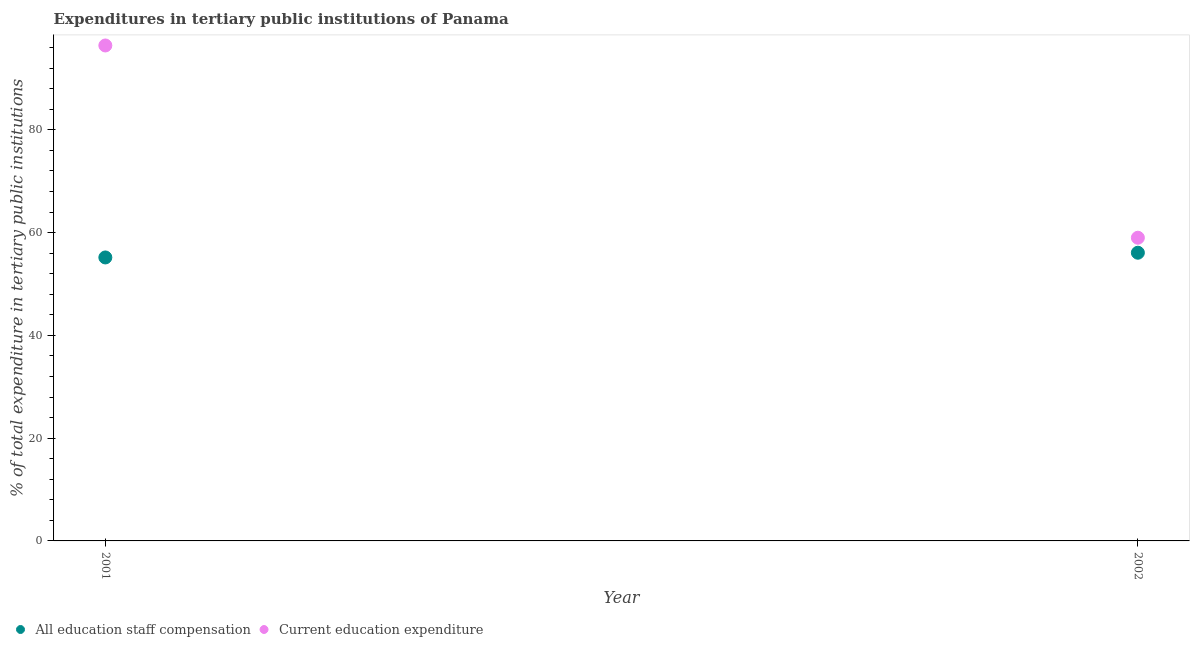Is the number of dotlines equal to the number of legend labels?
Your answer should be compact. Yes. What is the expenditure in education in 2001?
Ensure brevity in your answer.  96.4. Across all years, what is the maximum expenditure in education?
Make the answer very short. 96.4. Across all years, what is the minimum expenditure in staff compensation?
Keep it short and to the point. 55.16. In which year was the expenditure in staff compensation maximum?
Keep it short and to the point. 2002. What is the total expenditure in staff compensation in the graph?
Offer a terse response. 111.24. What is the difference between the expenditure in staff compensation in 2001 and that in 2002?
Ensure brevity in your answer.  -0.92. What is the difference between the expenditure in staff compensation in 2001 and the expenditure in education in 2002?
Ensure brevity in your answer.  -3.84. What is the average expenditure in staff compensation per year?
Provide a succinct answer. 55.62. In the year 2001, what is the difference between the expenditure in staff compensation and expenditure in education?
Offer a terse response. -41.25. In how many years, is the expenditure in education greater than 44 %?
Keep it short and to the point. 2. What is the ratio of the expenditure in staff compensation in 2001 to that in 2002?
Ensure brevity in your answer.  0.98. Is the expenditure in staff compensation in 2001 less than that in 2002?
Ensure brevity in your answer.  Yes. How many years are there in the graph?
Offer a terse response. 2. Are the values on the major ticks of Y-axis written in scientific E-notation?
Your response must be concise. No. Does the graph contain any zero values?
Provide a succinct answer. No. Where does the legend appear in the graph?
Offer a very short reply. Bottom left. How many legend labels are there?
Offer a very short reply. 2. How are the legend labels stacked?
Provide a short and direct response. Horizontal. What is the title of the graph?
Offer a very short reply. Expenditures in tertiary public institutions of Panama. What is the label or title of the Y-axis?
Provide a succinct answer. % of total expenditure in tertiary public institutions. What is the % of total expenditure in tertiary public institutions in All education staff compensation in 2001?
Offer a very short reply. 55.16. What is the % of total expenditure in tertiary public institutions of Current education expenditure in 2001?
Ensure brevity in your answer.  96.4. What is the % of total expenditure in tertiary public institutions of All education staff compensation in 2002?
Give a very brief answer. 56.08. What is the % of total expenditure in tertiary public institutions in Current education expenditure in 2002?
Your answer should be very brief. 58.99. Across all years, what is the maximum % of total expenditure in tertiary public institutions of All education staff compensation?
Provide a short and direct response. 56.08. Across all years, what is the maximum % of total expenditure in tertiary public institutions in Current education expenditure?
Your answer should be very brief. 96.4. Across all years, what is the minimum % of total expenditure in tertiary public institutions in All education staff compensation?
Your answer should be very brief. 55.16. Across all years, what is the minimum % of total expenditure in tertiary public institutions of Current education expenditure?
Your response must be concise. 58.99. What is the total % of total expenditure in tertiary public institutions in All education staff compensation in the graph?
Offer a terse response. 111.24. What is the total % of total expenditure in tertiary public institutions of Current education expenditure in the graph?
Offer a very short reply. 155.4. What is the difference between the % of total expenditure in tertiary public institutions in All education staff compensation in 2001 and that in 2002?
Make the answer very short. -0.92. What is the difference between the % of total expenditure in tertiary public institutions of Current education expenditure in 2001 and that in 2002?
Make the answer very short. 37.41. What is the difference between the % of total expenditure in tertiary public institutions of All education staff compensation in 2001 and the % of total expenditure in tertiary public institutions of Current education expenditure in 2002?
Offer a very short reply. -3.84. What is the average % of total expenditure in tertiary public institutions in All education staff compensation per year?
Your answer should be very brief. 55.62. What is the average % of total expenditure in tertiary public institutions of Current education expenditure per year?
Provide a short and direct response. 77.7. In the year 2001, what is the difference between the % of total expenditure in tertiary public institutions in All education staff compensation and % of total expenditure in tertiary public institutions in Current education expenditure?
Your answer should be very brief. -41.25. In the year 2002, what is the difference between the % of total expenditure in tertiary public institutions of All education staff compensation and % of total expenditure in tertiary public institutions of Current education expenditure?
Your answer should be very brief. -2.92. What is the ratio of the % of total expenditure in tertiary public institutions of All education staff compensation in 2001 to that in 2002?
Provide a short and direct response. 0.98. What is the ratio of the % of total expenditure in tertiary public institutions of Current education expenditure in 2001 to that in 2002?
Provide a succinct answer. 1.63. What is the difference between the highest and the second highest % of total expenditure in tertiary public institutions in All education staff compensation?
Your response must be concise. 0.92. What is the difference between the highest and the second highest % of total expenditure in tertiary public institutions in Current education expenditure?
Offer a very short reply. 37.41. What is the difference between the highest and the lowest % of total expenditure in tertiary public institutions in All education staff compensation?
Give a very brief answer. 0.92. What is the difference between the highest and the lowest % of total expenditure in tertiary public institutions in Current education expenditure?
Keep it short and to the point. 37.41. 